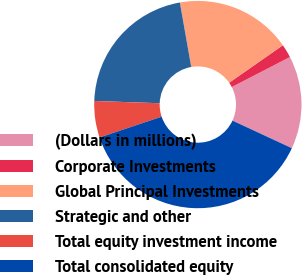Convert chart. <chart><loc_0><loc_0><loc_500><loc_500><pie_chart><fcel>(Dollars in millions)<fcel>Corporate Investments<fcel>Global Principal Investments<fcel>Strategic and other<fcel>Total equity investment income<fcel>Total consolidated equity<nl><fcel>14.5%<fcel>2.11%<fcel>18.08%<fcel>21.67%<fcel>5.7%<fcel>37.94%<nl></chart> 